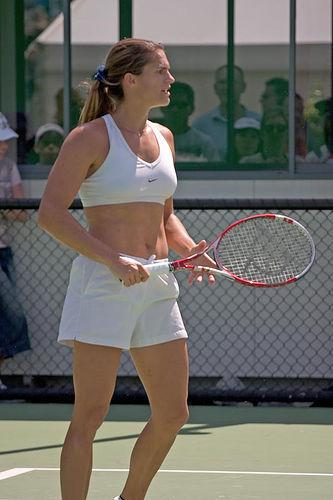Provide a short description of the scene in the image. A young female tennis player is holding a red and white racket on a court, wearing a sports bra, white shorts, and a cap, while being watched by spectators. What type of clothing is the tennis player wearing? The tennis player is wearing a white and black sports bra and white shorts. What is the color of the tennis racket the girl is holding? The tennis racket is white and red in color. Identify the type of sport being played in the image. The sport being played in the image is tennis. Count the number of people in the image who appear to be watching the tennis game. There are 8 groups of people watching the tennis game. Describe the main object that the girl is interacting with. The girl is interacting with a white and red tennis racket. Provide a caption for the image that highlights the girl's sportswear. "A focused tennis player in stylish white and black sportswear, ready for action." How would you rate the quality of this image? The image quality is good; objects and subjects are clearly identifiable. Explain the possible reasons why people are attracted to the scene in this image. People are attracted to the scene because it captures the competitive spirit, skill, and commitment of a young female tennis player in action. Analyze the image sentiment by describing the atmosphere and emotions conveyed. The image conveys a competitive and focused atmosphere, as the tennis player seems determined and the spectators are intently watching the game. 